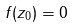Convert formula to latex. <formula><loc_0><loc_0><loc_500><loc_500>f ( z _ { 0 } ) = 0</formula> 